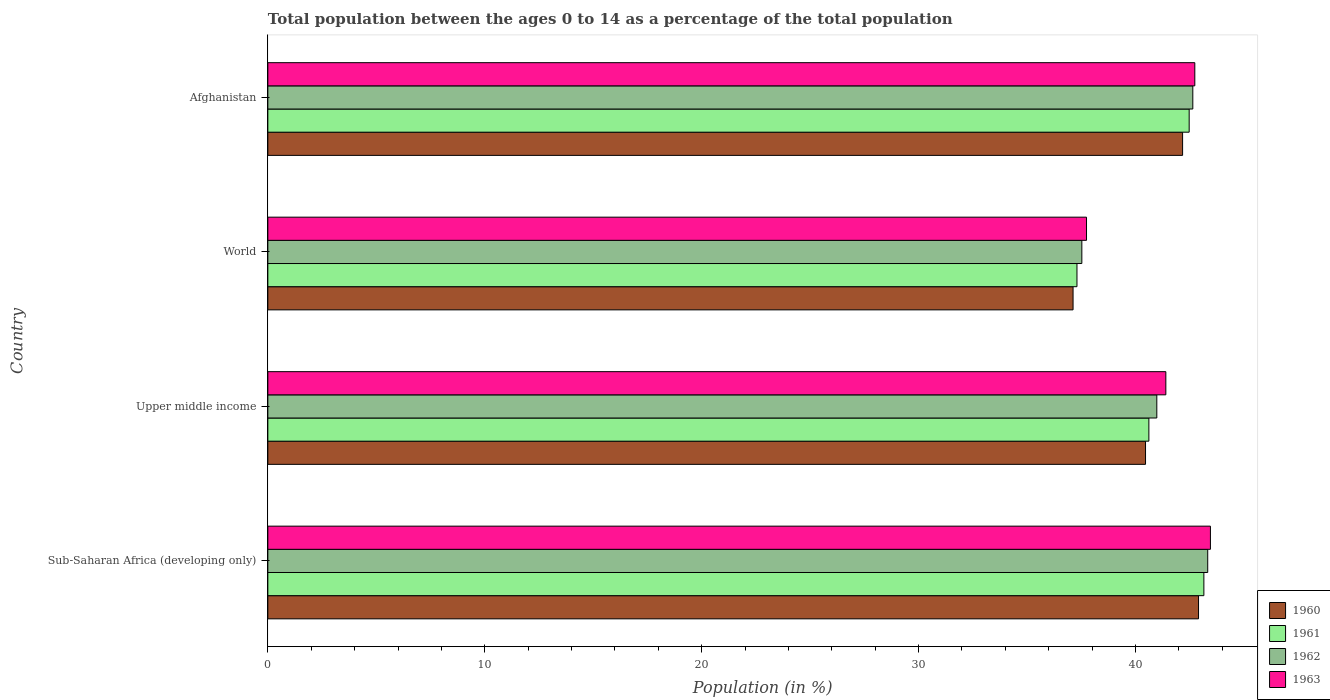How many different coloured bars are there?
Provide a short and direct response. 4. How many bars are there on the 2nd tick from the top?
Make the answer very short. 4. What is the label of the 3rd group of bars from the top?
Give a very brief answer. Upper middle income. In how many cases, is the number of bars for a given country not equal to the number of legend labels?
Your answer should be very brief. 0. What is the percentage of the population ages 0 to 14 in 1961 in Afghanistan?
Your answer should be very brief. 42.47. Across all countries, what is the maximum percentage of the population ages 0 to 14 in 1962?
Your answer should be very brief. 43.33. Across all countries, what is the minimum percentage of the population ages 0 to 14 in 1962?
Your answer should be compact. 37.53. In which country was the percentage of the population ages 0 to 14 in 1960 maximum?
Offer a terse response. Sub-Saharan Africa (developing only). In which country was the percentage of the population ages 0 to 14 in 1960 minimum?
Offer a terse response. World. What is the total percentage of the population ages 0 to 14 in 1960 in the graph?
Make the answer very short. 162.66. What is the difference between the percentage of the population ages 0 to 14 in 1960 in Afghanistan and that in World?
Your response must be concise. 5.05. What is the difference between the percentage of the population ages 0 to 14 in 1962 in Sub-Saharan Africa (developing only) and the percentage of the population ages 0 to 14 in 1961 in World?
Ensure brevity in your answer.  6.03. What is the average percentage of the population ages 0 to 14 in 1961 per country?
Your answer should be very brief. 40.89. What is the difference between the percentage of the population ages 0 to 14 in 1960 and percentage of the population ages 0 to 14 in 1963 in Sub-Saharan Africa (developing only)?
Provide a short and direct response. -0.55. In how many countries, is the percentage of the population ages 0 to 14 in 1963 greater than 22 ?
Offer a terse response. 4. What is the ratio of the percentage of the population ages 0 to 14 in 1962 in Upper middle income to that in World?
Your response must be concise. 1.09. What is the difference between the highest and the second highest percentage of the population ages 0 to 14 in 1962?
Provide a succinct answer. 0.69. What is the difference between the highest and the lowest percentage of the population ages 0 to 14 in 1961?
Make the answer very short. 5.85. In how many countries, is the percentage of the population ages 0 to 14 in 1962 greater than the average percentage of the population ages 0 to 14 in 1962 taken over all countries?
Ensure brevity in your answer.  2. Is the sum of the percentage of the population ages 0 to 14 in 1963 in Upper middle income and World greater than the maximum percentage of the population ages 0 to 14 in 1962 across all countries?
Make the answer very short. Yes. Is it the case that in every country, the sum of the percentage of the population ages 0 to 14 in 1963 and percentage of the population ages 0 to 14 in 1962 is greater than the sum of percentage of the population ages 0 to 14 in 1960 and percentage of the population ages 0 to 14 in 1961?
Offer a terse response. No. What does the 3rd bar from the top in World represents?
Ensure brevity in your answer.  1961. What does the 3rd bar from the bottom in World represents?
Your response must be concise. 1962. What is the difference between two consecutive major ticks on the X-axis?
Your response must be concise. 10. Are the values on the major ticks of X-axis written in scientific E-notation?
Your answer should be very brief. No. Where does the legend appear in the graph?
Provide a succinct answer. Bottom right. How many legend labels are there?
Provide a succinct answer. 4. What is the title of the graph?
Keep it short and to the point. Total population between the ages 0 to 14 as a percentage of the total population. Does "2003" appear as one of the legend labels in the graph?
Provide a short and direct response. No. What is the label or title of the X-axis?
Your answer should be compact. Population (in %). What is the Population (in %) in 1960 in Sub-Saharan Africa (developing only)?
Provide a short and direct response. 42.91. What is the Population (in %) of 1961 in Sub-Saharan Africa (developing only)?
Your response must be concise. 43.15. What is the Population (in %) of 1962 in Sub-Saharan Africa (developing only)?
Ensure brevity in your answer.  43.33. What is the Population (in %) of 1963 in Sub-Saharan Africa (developing only)?
Provide a short and direct response. 43.45. What is the Population (in %) in 1960 in Upper middle income?
Make the answer very short. 40.46. What is the Population (in %) of 1961 in Upper middle income?
Ensure brevity in your answer.  40.62. What is the Population (in %) of 1962 in Upper middle income?
Keep it short and to the point. 40.98. What is the Population (in %) of 1963 in Upper middle income?
Provide a succinct answer. 41.4. What is the Population (in %) of 1960 in World?
Your answer should be compact. 37.12. What is the Population (in %) of 1961 in World?
Provide a succinct answer. 37.3. What is the Population (in %) in 1962 in World?
Make the answer very short. 37.53. What is the Population (in %) in 1963 in World?
Keep it short and to the point. 37.74. What is the Population (in %) in 1960 in Afghanistan?
Make the answer very short. 42.17. What is the Population (in %) in 1961 in Afghanistan?
Offer a terse response. 42.47. What is the Population (in %) of 1962 in Afghanistan?
Give a very brief answer. 42.64. What is the Population (in %) in 1963 in Afghanistan?
Offer a terse response. 42.73. Across all countries, what is the maximum Population (in %) in 1960?
Ensure brevity in your answer.  42.91. Across all countries, what is the maximum Population (in %) of 1961?
Offer a very short reply. 43.15. Across all countries, what is the maximum Population (in %) of 1962?
Your answer should be compact. 43.33. Across all countries, what is the maximum Population (in %) of 1963?
Your answer should be very brief. 43.45. Across all countries, what is the minimum Population (in %) in 1960?
Make the answer very short. 37.12. Across all countries, what is the minimum Population (in %) of 1961?
Your response must be concise. 37.3. Across all countries, what is the minimum Population (in %) of 1962?
Your response must be concise. 37.53. Across all countries, what is the minimum Population (in %) of 1963?
Provide a short and direct response. 37.74. What is the total Population (in %) of 1960 in the graph?
Provide a short and direct response. 162.66. What is the total Population (in %) of 1961 in the graph?
Your answer should be very brief. 163.54. What is the total Population (in %) in 1962 in the graph?
Provide a short and direct response. 164.48. What is the total Population (in %) of 1963 in the graph?
Ensure brevity in your answer.  165.33. What is the difference between the Population (in %) in 1960 in Sub-Saharan Africa (developing only) and that in Upper middle income?
Your answer should be compact. 2.44. What is the difference between the Population (in %) of 1961 in Sub-Saharan Africa (developing only) and that in Upper middle income?
Offer a terse response. 2.54. What is the difference between the Population (in %) in 1962 in Sub-Saharan Africa (developing only) and that in Upper middle income?
Give a very brief answer. 2.35. What is the difference between the Population (in %) in 1963 in Sub-Saharan Africa (developing only) and that in Upper middle income?
Give a very brief answer. 2.06. What is the difference between the Population (in %) of 1960 in Sub-Saharan Africa (developing only) and that in World?
Your response must be concise. 5.78. What is the difference between the Population (in %) of 1961 in Sub-Saharan Africa (developing only) and that in World?
Offer a terse response. 5.85. What is the difference between the Population (in %) of 1962 in Sub-Saharan Africa (developing only) and that in World?
Ensure brevity in your answer.  5.8. What is the difference between the Population (in %) of 1963 in Sub-Saharan Africa (developing only) and that in World?
Your response must be concise. 5.71. What is the difference between the Population (in %) in 1960 in Sub-Saharan Africa (developing only) and that in Afghanistan?
Provide a succinct answer. 0.74. What is the difference between the Population (in %) in 1961 in Sub-Saharan Africa (developing only) and that in Afghanistan?
Make the answer very short. 0.68. What is the difference between the Population (in %) in 1962 in Sub-Saharan Africa (developing only) and that in Afghanistan?
Your response must be concise. 0.69. What is the difference between the Population (in %) in 1963 in Sub-Saharan Africa (developing only) and that in Afghanistan?
Provide a short and direct response. 0.72. What is the difference between the Population (in %) of 1960 in Upper middle income and that in World?
Your response must be concise. 3.34. What is the difference between the Population (in %) in 1961 in Upper middle income and that in World?
Offer a terse response. 3.31. What is the difference between the Population (in %) in 1962 in Upper middle income and that in World?
Ensure brevity in your answer.  3.46. What is the difference between the Population (in %) of 1963 in Upper middle income and that in World?
Provide a short and direct response. 3.66. What is the difference between the Population (in %) in 1960 in Upper middle income and that in Afghanistan?
Your response must be concise. -1.71. What is the difference between the Population (in %) of 1961 in Upper middle income and that in Afghanistan?
Offer a terse response. -1.86. What is the difference between the Population (in %) of 1962 in Upper middle income and that in Afghanistan?
Your response must be concise. -1.66. What is the difference between the Population (in %) of 1963 in Upper middle income and that in Afghanistan?
Your response must be concise. -1.34. What is the difference between the Population (in %) in 1960 in World and that in Afghanistan?
Your answer should be compact. -5.05. What is the difference between the Population (in %) in 1961 in World and that in Afghanistan?
Your answer should be compact. -5.17. What is the difference between the Population (in %) of 1962 in World and that in Afghanistan?
Make the answer very short. -5.12. What is the difference between the Population (in %) in 1963 in World and that in Afghanistan?
Your answer should be very brief. -4.99. What is the difference between the Population (in %) in 1960 in Sub-Saharan Africa (developing only) and the Population (in %) in 1961 in Upper middle income?
Your answer should be compact. 2.29. What is the difference between the Population (in %) of 1960 in Sub-Saharan Africa (developing only) and the Population (in %) of 1962 in Upper middle income?
Provide a short and direct response. 1.92. What is the difference between the Population (in %) in 1960 in Sub-Saharan Africa (developing only) and the Population (in %) in 1963 in Upper middle income?
Give a very brief answer. 1.51. What is the difference between the Population (in %) of 1961 in Sub-Saharan Africa (developing only) and the Population (in %) of 1962 in Upper middle income?
Offer a very short reply. 2.17. What is the difference between the Population (in %) in 1961 in Sub-Saharan Africa (developing only) and the Population (in %) in 1963 in Upper middle income?
Give a very brief answer. 1.75. What is the difference between the Population (in %) in 1962 in Sub-Saharan Africa (developing only) and the Population (in %) in 1963 in Upper middle income?
Your answer should be compact. 1.93. What is the difference between the Population (in %) of 1960 in Sub-Saharan Africa (developing only) and the Population (in %) of 1961 in World?
Offer a terse response. 5.6. What is the difference between the Population (in %) in 1960 in Sub-Saharan Africa (developing only) and the Population (in %) in 1962 in World?
Make the answer very short. 5.38. What is the difference between the Population (in %) in 1960 in Sub-Saharan Africa (developing only) and the Population (in %) in 1963 in World?
Make the answer very short. 5.16. What is the difference between the Population (in %) of 1961 in Sub-Saharan Africa (developing only) and the Population (in %) of 1962 in World?
Give a very brief answer. 5.63. What is the difference between the Population (in %) of 1961 in Sub-Saharan Africa (developing only) and the Population (in %) of 1963 in World?
Give a very brief answer. 5.41. What is the difference between the Population (in %) of 1962 in Sub-Saharan Africa (developing only) and the Population (in %) of 1963 in World?
Keep it short and to the point. 5.59. What is the difference between the Population (in %) in 1960 in Sub-Saharan Africa (developing only) and the Population (in %) in 1961 in Afghanistan?
Offer a terse response. 0.43. What is the difference between the Population (in %) in 1960 in Sub-Saharan Africa (developing only) and the Population (in %) in 1962 in Afghanistan?
Provide a succinct answer. 0.26. What is the difference between the Population (in %) in 1960 in Sub-Saharan Africa (developing only) and the Population (in %) in 1963 in Afghanistan?
Offer a very short reply. 0.17. What is the difference between the Population (in %) in 1961 in Sub-Saharan Africa (developing only) and the Population (in %) in 1962 in Afghanistan?
Keep it short and to the point. 0.51. What is the difference between the Population (in %) of 1961 in Sub-Saharan Africa (developing only) and the Population (in %) of 1963 in Afghanistan?
Your answer should be compact. 0.42. What is the difference between the Population (in %) of 1962 in Sub-Saharan Africa (developing only) and the Population (in %) of 1963 in Afghanistan?
Your response must be concise. 0.6. What is the difference between the Population (in %) in 1960 in Upper middle income and the Population (in %) in 1961 in World?
Your answer should be compact. 3.16. What is the difference between the Population (in %) of 1960 in Upper middle income and the Population (in %) of 1962 in World?
Provide a succinct answer. 2.94. What is the difference between the Population (in %) in 1960 in Upper middle income and the Population (in %) in 1963 in World?
Offer a terse response. 2.72. What is the difference between the Population (in %) in 1961 in Upper middle income and the Population (in %) in 1962 in World?
Keep it short and to the point. 3.09. What is the difference between the Population (in %) of 1961 in Upper middle income and the Population (in %) of 1963 in World?
Offer a very short reply. 2.87. What is the difference between the Population (in %) of 1962 in Upper middle income and the Population (in %) of 1963 in World?
Keep it short and to the point. 3.24. What is the difference between the Population (in %) of 1960 in Upper middle income and the Population (in %) of 1961 in Afghanistan?
Make the answer very short. -2.01. What is the difference between the Population (in %) in 1960 in Upper middle income and the Population (in %) in 1962 in Afghanistan?
Keep it short and to the point. -2.18. What is the difference between the Population (in %) in 1960 in Upper middle income and the Population (in %) in 1963 in Afghanistan?
Keep it short and to the point. -2.27. What is the difference between the Population (in %) of 1961 in Upper middle income and the Population (in %) of 1962 in Afghanistan?
Keep it short and to the point. -2.03. What is the difference between the Population (in %) of 1961 in Upper middle income and the Population (in %) of 1963 in Afghanistan?
Your response must be concise. -2.12. What is the difference between the Population (in %) of 1962 in Upper middle income and the Population (in %) of 1963 in Afghanistan?
Provide a succinct answer. -1.75. What is the difference between the Population (in %) in 1960 in World and the Population (in %) in 1961 in Afghanistan?
Provide a succinct answer. -5.35. What is the difference between the Population (in %) of 1960 in World and the Population (in %) of 1962 in Afghanistan?
Your answer should be very brief. -5.52. What is the difference between the Population (in %) in 1960 in World and the Population (in %) in 1963 in Afghanistan?
Offer a very short reply. -5.61. What is the difference between the Population (in %) of 1961 in World and the Population (in %) of 1962 in Afghanistan?
Your response must be concise. -5.34. What is the difference between the Population (in %) in 1961 in World and the Population (in %) in 1963 in Afghanistan?
Provide a succinct answer. -5.43. What is the difference between the Population (in %) in 1962 in World and the Population (in %) in 1963 in Afghanistan?
Ensure brevity in your answer.  -5.21. What is the average Population (in %) in 1960 per country?
Your response must be concise. 40.67. What is the average Population (in %) of 1961 per country?
Make the answer very short. 40.89. What is the average Population (in %) of 1962 per country?
Your response must be concise. 41.12. What is the average Population (in %) in 1963 per country?
Your answer should be very brief. 41.33. What is the difference between the Population (in %) in 1960 and Population (in %) in 1961 in Sub-Saharan Africa (developing only)?
Your answer should be compact. -0.25. What is the difference between the Population (in %) in 1960 and Population (in %) in 1962 in Sub-Saharan Africa (developing only)?
Offer a terse response. -0.42. What is the difference between the Population (in %) in 1960 and Population (in %) in 1963 in Sub-Saharan Africa (developing only)?
Your answer should be compact. -0.55. What is the difference between the Population (in %) in 1961 and Population (in %) in 1962 in Sub-Saharan Africa (developing only)?
Provide a succinct answer. -0.18. What is the difference between the Population (in %) of 1961 and Population (in %) of 1963 in Sub-Saharan Africa (developing only)?
Ensure brevity in your answer.  -0.3. What is the difference between the Population (in %) of 1962 and Population (in %) of 1963 in Sub-Saharan Africa (developing only)?
Provide a succinct answer. -0.12. What is the difference between the Population (in %) in 1960 and Population (in %) in 1961 in Upper middle income?
Keep it short and to the point. -0.15. What is the difference between the Population (in %) of 1960 and Population (in %) of 1962 in Upper middle income?
Give a very brief answer. -0.52. What is the difference between the Population (in %) of 1960 and Population (in %) of 1963 in Upper middle income?
Keep it short and to the point. -0.94. What is the difference between the Population (in %) of 1961 and Population (in %) of 1962 in Upper middle income?
Your answer should be very brief. -0.37. What is the difference between the Population (in %) in 1961 and Population (in %) in 1963 in Upper middle income?
Provide a succinct answer. -0.78. What is the difference between the Population (in %) in 1962 and Population (in %) in 1963 in Upper middle income?
Provide a short and direct response. -0.42. What is the difference between the Population (in %) in 1960 and Population (in %) in 1961 in World?
Provide a succinct answer. -0.18. What is the difference between the Population (in %) of 1960 and Population (in %) of 1962 in World?
Offer a terse response. -0.4. What is the difference between the Population (in %) in 1960 and Population (in %) in 1963 in World?
Ensure brevity in your answer.  -0.62. What is the difference between the Population (in %) in 1961 and Population (in %) in 1962 in World?
Offer a terse response. -0.22. What is the difference between the Population (in %) in 1961 and Population (in %) in 1963 in World?
Offer a very short reply. -0.44. What is the difference between the Population (in %) of 1962 and Population (in %) of 1963 in World?
Your answer should be very brief. -0.22. What is the difference between the Population (in %) in 1960 and Population (in %) in 1961 in Afghanistan?
Make the answer very short. -0.3. What is the difference between the Population (in %) in 1960 and Population (in %) in 1962 in Afghanistan?
Offer a terse response. -0.47. What is the difference between the Population (in %) in 1960 and Population (in %) in 1963 in Afghanistan?
Ensure brevity in your answer.  -0.56. What is the difference between the Population (in %) of 1961 and Population (in %) of 1962 in Afghanistan?
Your response must be concise. -0.17. What is the difference between the Population (in %) of 1961 and Population (in %) of 1963 in Afghanistan?
Make the answer very short. -0.26. What is the difference between the Population (in %) of 1962 and Population (in %) of 1963 in Afghanistan?
Ensure brevity in your answer.  -0.09. What is the ratio of the Population (in %) of 1960 in Sub-Saharan Africa (developing only) to that in Upper middle income?
Provide a short and direct response. 1.06. What is the ratio of the Population (in %) in 1961 in Sub-Saharan Africa (developing only) to that in Upper middle income?
Keep it short and to the point. 1.06. What is the ratio of the Population (in %) in 1962 in Sub-Saharan Africa (developing only) to that in Upper middle income?
Make the answer very short. 1.06. What is the ratio of the Population (in %) in 1963 in Sub-Saharan Africa (developing only) to that in Upper middle income?
Ensure brevity in your answer.  1.05. What is the ratio of the Population (in %) of 1960 in Sub-Saharan Africa (developing only) to that in World?
Keep it short and to the point. 1.16. What is the ratio of the Population (in %) in 1961 in Sub-Saharan Africa (developing only) to that in World?
Ensure brevity in your answer.  1.16. What is the ratio of the Population (in %) of 1962 in Sub-Saharan Africa (developing only) to that in World?
Keep it short and to the point. 1.15. What is the ratio of the Population (in %) of 1963 in Sub-Saharan Africa (developing only) to that in World?
Offer a very short reply. 1.15. What is the ratio of the Population (in %) in 1960 in Sub-Saharan Africa (developing only) to that in Afghanistan?
Provide a short and direct response. 1.02. What is the ratio of the Population (in %) in 1961 in Sub-Saharan Africa (developing only) to that in Afghanistan?
Offer a very short reply. 1.02. What is the ratio of the Population (in %) of 1962 in Sub-Saharan Africa (developing only) to that in Afghanistan?
Your response must be concise. 1.02. What is the ratio of the Population (in %) of 1963 in Sub-Saharan Africa (developing only) to that in Afghanistan?
Your response must be concise. 1.02. What is the ratio of the Population (in %) of 1960 in Upper middle income to that in World?
Ensure brevity in your answer.  1.09. What is the ratio of the Population (in %) of 1961 in Upper middle income to that in World?
Offer a very short reply. 1.09. What is the ratio of the Population (in %) in 1962 in Upper middle income to that in World?
Your response must be concise. 1.09. What is the ratio of the Population (in %) of 1963 in Upper middle income to that in World?
Provide a succinct answer. 1.1. What is the ratio of the Population (in %) in 1960 in Upper middle income to that in Afghanistan?
Ensure brevity in your answer.  0.96. What is the ratio of the Population (in %) in 1961 in Upper middle income to that in Afghanistan?
Offer a terse response. 0.96. What is the ratio of the Population (in %) of 1962 in Upper middle income to that in Afghanistan?
Your response must be concise. 0.96. What is the ratio of the Population (in %) in 1963 in Upper middle income to that in Afghanistan?
Give a very brief answer. 0.97. What is the ratio of the Population (in %) in 1960 in World to that in Afghanistan?
Provide a short and direct response. 0.88. What is the ratio of the Population (in %) of 1961 in World to that in Afghanistan?
Give a very brief answer. 0.88. What is the ratio of the Population (in %) in 1962 in World to that in Afghanistan?
Offer a terse response. 0.88. What is the ratio of the Population (in %) in 1963 in World to that in Afghanistan?
Give a very brief answer. 0.88. What is the difference between the highest and the second highest Population (in %) of 1960?
Your answer should be very brief. 0.74. What is the difference between the highest and the second highest Population (in %) in 1961?
Offer a very short reply. 0.68. What is the difference between the highest and the second highest Population (in %) of 1962?
Your response must be concise. 0.69. What is the difference between the highest and the second highest Population (in %) in 1963?
Keep it short and to the point. 0.72. What is the difference between the highest and the lowest Population (in %) of 1960?
Keep it short and to the point. 5.78. What is the difference between the highest and the lowest Population (in %) of 1961?
Your answer should be compact. 5.85. What is the difference between the highest and the lowest Population (in %) in 1962?
Your answer should be very brief. 5.8. What is the difference between the highest and the lowest Population (in %) of 1963?
Offer a very short reply. 5.71. 